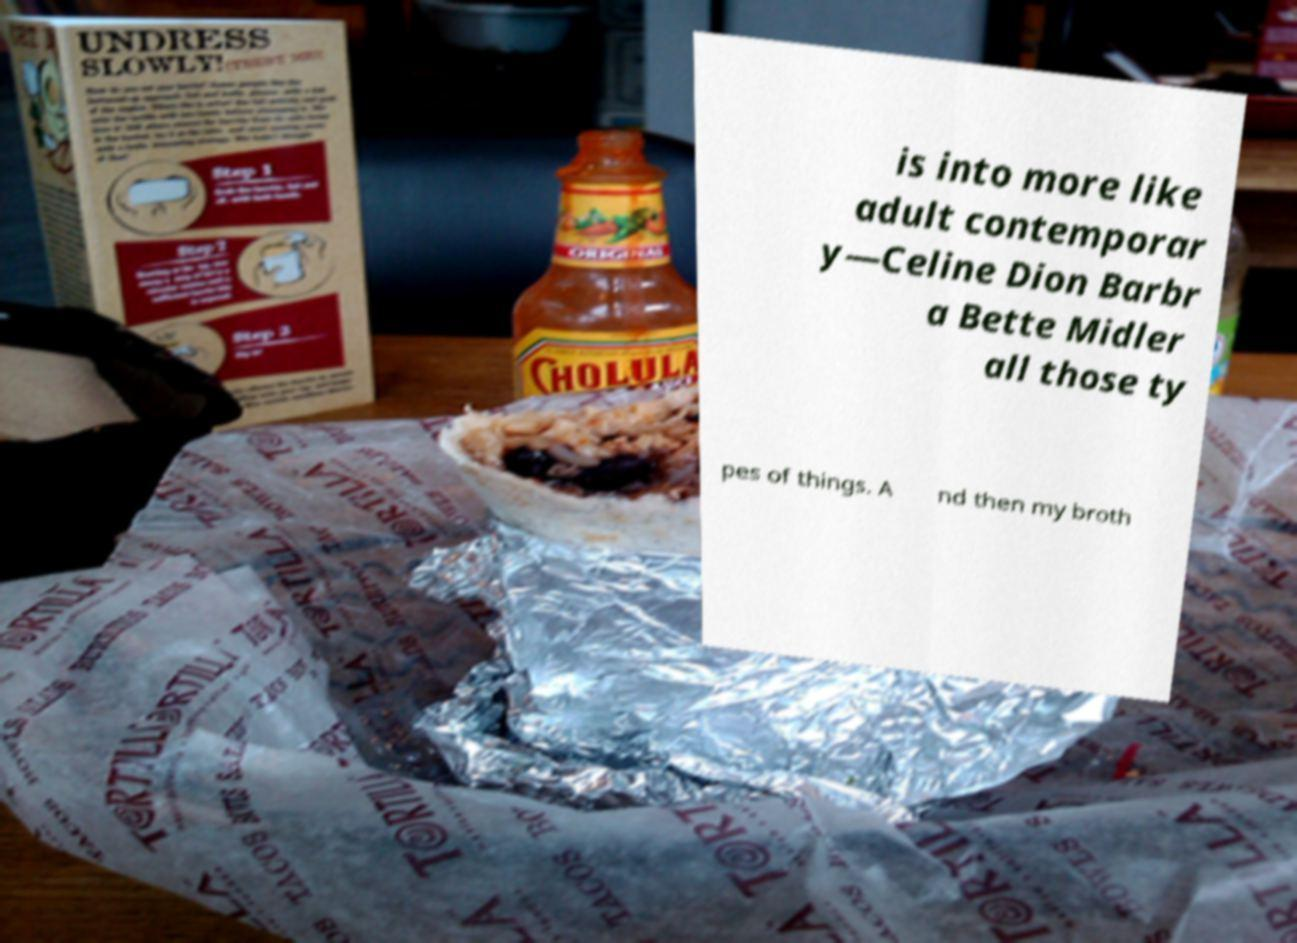Please read and relay the text visible in this image. What does it say? is into more like adult contemporar y—Celine Dion Barbr a Bette Midler all those ty pes of things. A nd then my broth 